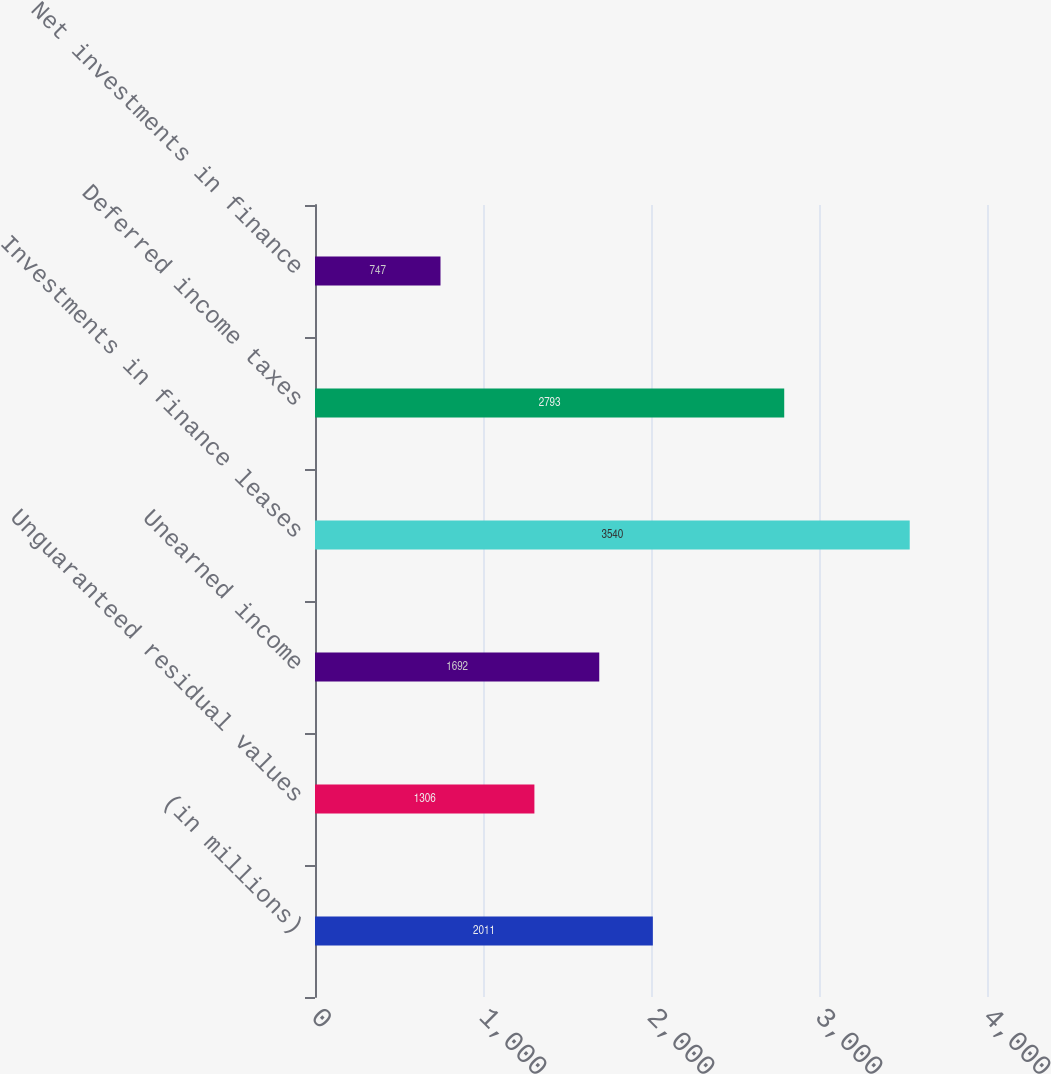<chart> <loc_0><loc_0><loc_500><loc_500><bar_chart><fcel>(in millions)<fcel>Unguaranteed residual values<fcel>Unearned income<fcel>Investments in finance leases<fcel>Deferred income taxes<fcel>Net investments in finance<nl><fcel>2011<fcel>1306<fcel>1692<fcel>3540<fcel>2793<fcel>747<nl></chart> 